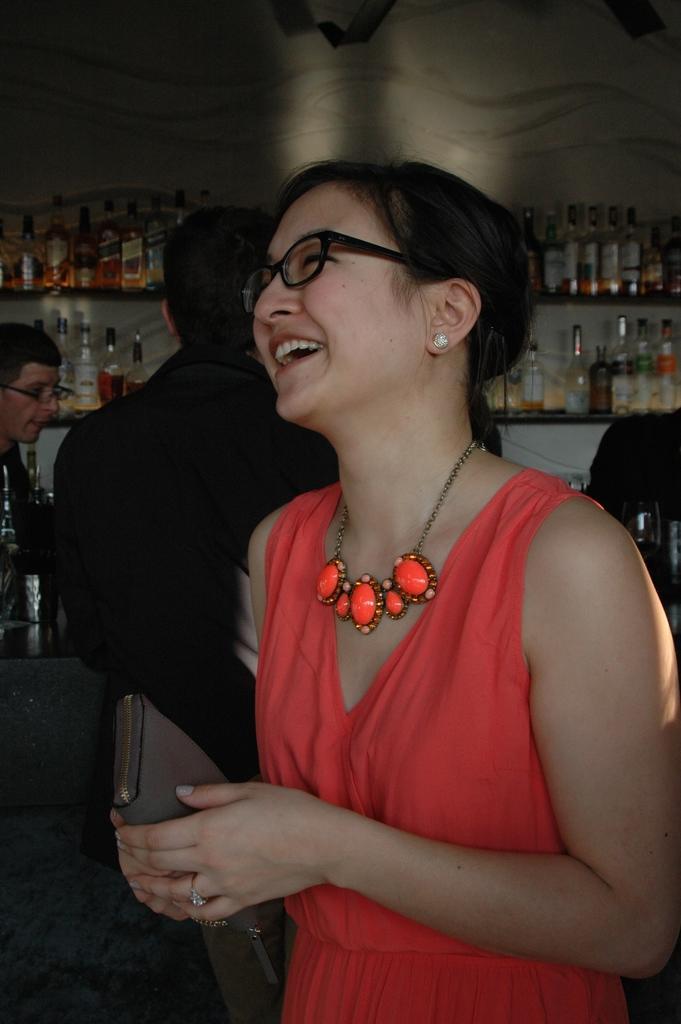Can you describe this image briefly? In this image I can see the group of people with different color dresses and two people with the specs. In the background I can see few wine bottles on the shelves. 